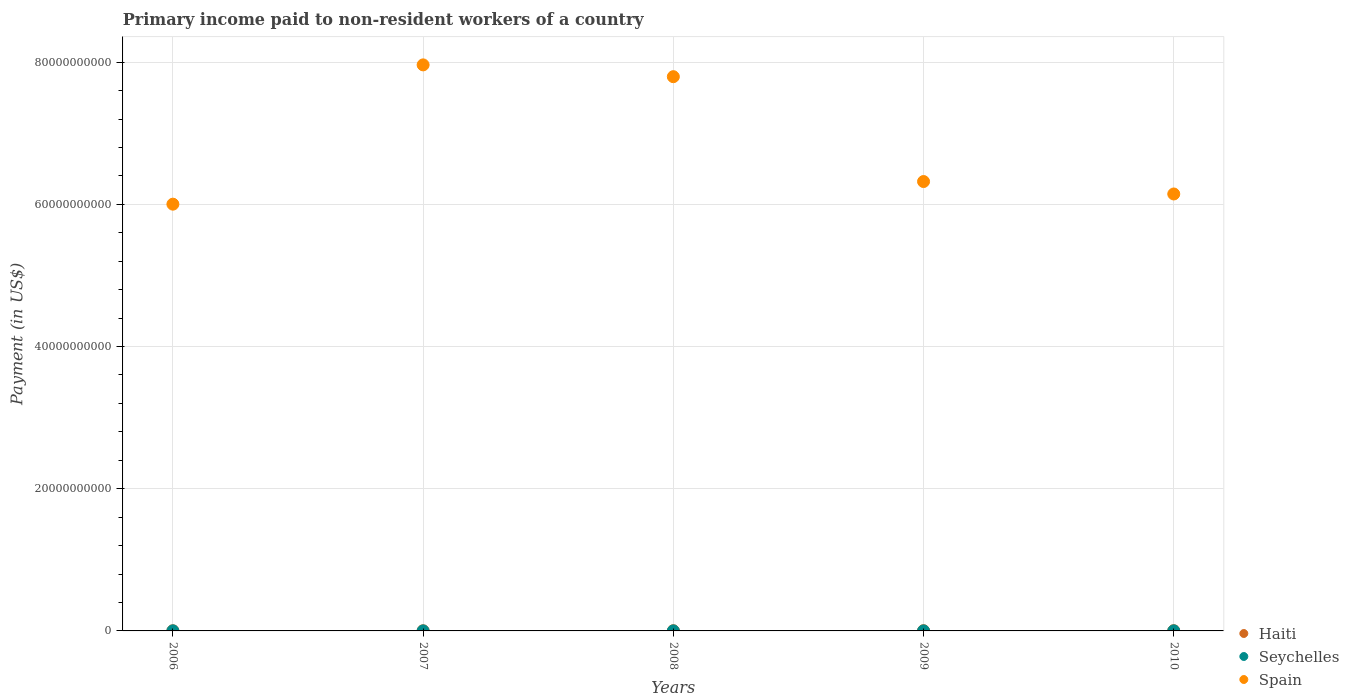Is the number of dotlines equal to the number of legend labels?
Your answer should be compact. Yes. What is the amount paid to workers in Spain in 2010?
Provide a succinct answer. 6.15e+1. Across all years, what is the maximum amount paid to workers in Seychelles?
Your answer should be compact. 1.03e+07. Across all years, what is the minimum amount paid to workers in Seychelles?
Your response must be concise. 3.58e+06. In which year was the amount paid to workers in Seychelles maximum?
Provide a succinct answer. 2006. What is the total amount paid to workers in Seychelles in the graph?
Provide a succinct answer. 3.19e+07. What is the difference between the amount paid to workers in Seychelles in 2006 and that in 2010?
Your answer should be very brief. 6.96e+05. What is the difference between the amount paid to workers in Haiti in 2009 and the amount paid to workers in Seychelles in 2008?
Keep it short and to the point. 2.62e+07. What is the average amount paid to workers in Spain per year?
Offer a terse response. 6.85e+1. In the year 2009, what is the difference between the amount paid to workers in Haiti and amount paid to workers in Spain?
Provide a succinct answer. -6.32e+1. In how many years, is the amount paid to workers in Haiti greater than 60000000000 US$?
Keep it short and to the point. 0. What is the ratio of the amount paid to workers in Seychelles in 2008 to that in 2010?
Make the answer very short. 0.51. Is the amount paid to workers in Haiti in 2007 less than that in 2009?
Keep it short and to the point. Yes. What is the difference between the highest and the second highest amount paid to workers in Spain?
Your response must be concise. 1.66e+09. What is the difference between the highest and the lowest amount paid to workers in Spain?
Provide a short and direct response. 1.96e+1. Is it the case that in every year, the sum of the amount paid to workers in Spain and amount paid to workers in Seychelles  is greater than the amount paid to workers in Haiti?
Your answer should be compact. Yes. Does the amount paid to workers in Seychelles monotonically increase over the years?
Make the answer very short. No. Is the amount paid to workers in Haiti strictly greater than the amount paid to workers in Seychelles over the years?
Make the answer very short. Yes. How many dotlines are there?
Provide a succinct answer. 3. How many years are there in the graph?
Your answer should be compact. 5. What is the difference between two consecutive major ticks on the Y-axis?
Your answer should be very brief. 2.00e+1. Are the values on the major ticks of Y-axis written in scientific E-notation?
Your response must be concise. No. Does the graph contain grids?
Make the answer very short. Yes. Where does the legend appear in the graph?
Your response must be concise. Bottom right. How many legend labels are there?
Ensure brevity in your answer.  3. How are the legend labels stacked?
Keep it short and to the point. Vertical. What is the title of the graph?
Keep it short and to the point. Primary income paid to non-resident workers of a country. What is the label or title of the X-axis?
Your answer should be very brief. Years. What is the label or title of the Y-axis?
Make the answer very short. Payment (in US$). What is the Payment (in US$) in Haiti in 2006?
Offer a very short reply. 2.08e+07. What is the Payment (in US$) in Seychelles in 2006?
Your answer should be compact. 1.03e+07. What is the Payment (in US$) of Spain in 2006?
Your response must be concise. 6.00e+1. What is the Payment (in US$) of Haiti in 2007?
Your answer should be compact. 2.18e+07. What is the Payment (in US$) in Seychelles in 2007?
Your answer should be very brief. 3.58e+06. What is the Payment (in US$) of Spain in 2007?
Give a very brief answer. 7.96e+1. What is the Payment (in US$) of Haiti in 2008?
Ensure brevity in your answer.  2.80e+07. What is the Payment (in US$) in Seychelles in 2008?
Your response must be concise. 4.88e+06. What is the Payment (in US$) of Spain in 2008?
Offer a terse response. 7.80e+1. What is the Payment (in US$) in Haiti in 2009?
Make the answer very short. 3.11e+07. What is the Payment (in US$) in Seychelles in 2009?
Your answer should be compact. 3.65e+06. What is the Payment (in US$) of Spain in 2009?
Provide a short and direct response. 6.32e+1. What is the Payment (in US$) in Haiti in 2010?
Provide a short and direct response. 3.27e+07. What is the Payment (in US$) in Seychelles in 2010?
Your answer should be compact. 9.57e+06. What is the Payment (in US$) of Spain in 2010?
Ensure brevity in your answer.  6.15e+1. Across all years, what is the maximum Payment (in US$) in Haiti?
Give a very brief answer. 3.27e+07. Across all years, what is the maximum Payment (in US$) of Seychelles?
Ensure brevity in your answer.  1.03e+07. Across all years, what is the maximum Payment (in US$) of Spain?
Keep it short and to the point. 7.96e+1. Across all years, what is the minimum Payment (in US$) in Haiti?
Offer a terse response. 2.08e+07. Across all years, what is the minimum Payment (in US$) in Seychelles?
Your answer should be compact. 3.58e+06. Across all years, what is the minimum Payment (in US$) in Spain?
Keep it short and to the point. 6.00e+1. What is the total Payment (in US$) in Haiti in the graph?
Give a very brief answer. 1.34e+08. What is the total Payment (in US$) in Seychelles in the graph?
Your answer should be compact. 3.19e+07. What is the total Payment (in US$) in Spain in the graph?
Offer a very short reply. 3.42e+11. What is the difference between the Payment (in US$) of Haiti in 2006 and that in 2007?
Your answer should be very brief. -9.59e+05. What is the difference between the Payment (in US$) in Seychelles in 2006 and that in 2007?
Keep it short and to the point. 6.69e+06. What is the difference between the Payment (in US$) of Spain in 2006 and that in 2007?
Keep it short and to the point. -1.96e+1. What is the difference between the Payment (in US$) of Haiti in 2006 and that in 2008?
Your response must be concise. -7.19e+06. What is the difference between the Payment (in US$) of Seychelles in 2006 and that in 2008?
Ensure brevity in your answer.  5.39e+06. What is the difference between the Payment (in US$) of Spain in 2006 and that in 2008?
Your answer should be compact. -1.79e+1. What is the difference between the Payment (in US$) of Haiti in 2006 and that in 2009?
Ensure brevity in your answer.  -1.03e+07. What is the difference between the Payment (in US$) of Seychelles in 2006 and that in 2009?
Keep it short and to the point. 6.62e+06. What is the difference between the Payment (in US$) in Spain in 2006 and that in 2009?
Your answer should be compact. -3.18e+09. What is the difference between the Payment (in US$) of Haiti in 2006 and that in 2010?
Provide a succinct answer. -1.19e+07. What is the difference between the Payment (in US$) of Seychelles in 2006 and that in 2010?
Offer a very short reply. 6.96e+05. What is the difference between the Payment (in US$) of Spain in 2006 and that in 2010?
Provide a succinct answer. -1.43e+09. What is the difference between the Payment (in US$) of Haiti in 2007 and that in 2008?
Give a very brief answer. -6.23e+06. What is the difference between the Payment (in US$) in Seychelles in 2007 and that in 2008?
Provide a succinct answer. -1.31e+06. What is the difference between the Payment (in US$) of Spain in 2007 and that in 2008?
Make the answer very short. 1.66e+09. What is the difference between the Payment (in US$) of Haiti in 2007 and that in 2009?
Your response must be concise. -9.33e+06. What is the difference between the Payment (in US$) in Seychelles in 2007 and that in 2009?
Offer a very short reply. -7.35e+04. What is the difference between the Payment (in US$) in Spain in 2007 and that in 2009?
Ensure brevity in your answer.  1.64e+1. What is the difference between the Payment (in US$) in Haiti in 2007 and that in 2010?
Your response must be concise. -1.09e+07. What is the difference between the Payment (in US$) in Seychelles in 2007 and that in 2010?
Offer a terse response. -6.00e+06. What is the difference between the Payment (in US$) in Spain in 2007 and that in 2010?
Your answer should be compact. 1.82e+1. What is the difference between the Payment (in US$) in Haiti in 2008 and that in 2009?
Your answer should be compact. -3.10e+06. What is the difference between the Payment (in US$) in Seychelles in 2008 and that in 2009?
Your answer should be compact. 1.23e+06. What is the difference between the Payment (in US$) of Spain in 2008 and that in 2009?
Keep it short and to the point. 1.47e+1. What is the difference between the Payment (in US$) in Haiti in 2008 and that in 2010?
Offer a very short reply. -4.68e+06. What is the difference between the Payment (in US$) of Seychelles in 2008 and that in 2010?
Your answer should be very brief. -4.69e+06. What is the difference between the Payment (in US$) of Spain in 2008 and that in 2010?
Make the answer very short. 1.65e+1. What is the difference between the Payment (in US$) of Haiti in 2009 and that in 2010?
Your response must be concise. -1.58e+06. What is the difference between the Payment (in US$) of Seychelles in 2009 and that in 2010?
Ensure brevity in your answer.  -5.92e+06. What is the difference between the Payment (in US$) in Spain in 2009 and that in 2010?
Provide a short and direct response. 1.75e+09. What is the difference between the Payment (in US$) in Haiti in 2006 and the Payment (in US$) in Seychelles in 2007?
Your answer should be compact. 1.73e+07. What is the difference between the Payment (in US$) in Haiti in 2006 and the Payment (in US$) in Spain in 2007?
Your answer should be very brief. -7.96e+1. What is the difference between the Payment (in US$) of Seychelles in 2006 and the Payment (in US$) of Spain in 2007?
Keep it short and to the point. -7.96e+1. What is the difference between the Payment (in US$) in Haiti in 2006 and the Payment (in US$) in Seychelles in 2008?
Ensure brevity in your answer.  1.60e+07. What is the difference between the Payment (in US$) of Haiti in 2006 and the Payment (in US$) of Spain in 2008?
Offer a very short reply. -7.79e+1. What is the difference between the Payment (in US$) in Seychelles in 2006 and the Payment (in US$) in Spain in 2008?
Your answer should be compact. -7.79e+1. What is the difference between the Payment (in US$) in Haiti in 2006 and the Payment (in US$) in Seychelles in 2009?
Your answer should be very brief. 1.72e+07. What is the difference between the Payment (in US$) in Haiti in 2006 and the Payment (in US$) in Spain in 2009?
Provide a short and direct response. -6.32e+1. What is the difference between the Payment (in US$) in Seychelles in 2006 and the Payment (in US$) in Spain in 2009?
Provide a short and direct response. -6.32e+1. What is the difference between the Payment (in US$) in Haiti in 2006 and the Payment (in US$) in Seychelles in 2010?
Make the answer very short. 1.13e+07. What is the difference between the Payment (in US$) in Haiti in 2006 and the Payment (in US$) in Spain in 2010?
Keep it short and to the point. -6.14e+1. What is the difference between the Payment (in US$) of Seychelles in 2006 and the Payment (in US$) of Spain in 2010?
Provide a short and direct response. -6.14e+1. What is the difference between the Payment (in US$) in Haiti in 2007 and the Payment (in US$) in Seychelles in 2008?
Keep it short and to the point. 1.69e+07. What is the difference between the Payment (in US$) of Haiti in 2007 and the Payment (in US$) of Spain in 2008?
Give a very brief answer. -7.79e+1. What is the difference between the Payment (in US$) in Seychelles in 2007 and the Payment (in US$) in Spain in 2008?
Your response must be concise. -7.80e+1. What is the difference between the Payment (in US$) in Haiti in 2007 and the Payment (in US$) in Seychelles in 2009?
Offer a terse response. 1.81e+07. What is the difference between the Payment (in US$) in Haiti in 2007 and the Payment (in US$) in Spain in 2009?
Provide a succinct answer. -6.32e+1. What is the difference between the Payment (in US$) of Seychelles in 2007 and the Payment (in US$) of Spain in 2009?
Offer a terse response. -6.32e+1. What is the difference between the Payment (in US$) of Haiti in 2007 and the Payment (in US$) of Seychelles in 2010?
Provide a succinct answer. 1.22e+07. What is the difference between the Payment (in US$) in Haiti in 2007 and the Payment (in US$) in Spain in 2010?
Keep it short and to the point. -6.14e+1. What is the difference between the Payment (in US$) of Seychelles in 2007 and the Payment (in US$) of Spain in 2010?
Your answer should be very brief. -6.15e+1. What is the difference between the Payment (in US$) in Haiti in 2008 and the Payment (in US$) in Seychelles in 2009?
Offer a terse response. 2.44e+07. What is the difference between the Payment (in US$) in Haiti in 2008 and the Payment (in US$) in Spain in 2009?
Provide a succinct answer. -6.32e+1. What is the difference between the Payment (in US$) in Seychelles in 2008 and the Payment (in US$) in Spain in 2009?
Ensure brevity in your answer.  -6.32e+1. What is the difference between the Payment (in US$) in Haiti in 2008 and the Payment (in US$) in Seychelles in 2010?
Give a very brief answer. 1.85e+07. What is the difference between the Payment (in US$) in Haiti in 2008 and the Payment (in US$) in Spain in 2010?
Your response must be concise. -6.14e+1. What is the difference between the Payment (in US$) in Seychelles in 2008 and the Payment (in US$) in Spain in 2010?
Offer a very short reply. -6.15e+1. What is the difference between the Payment (in US$) in Haiti in 2009 and the Payment (in US$) in Seychelles in 2010?
Provide a short and direct response. 2.16e+07. What is the difference between the Payment (in US$) of Haiti in 2009 and the Payment (in US$) of Spain in 2010?
Make the answer very short. -6.14e+1. What is the difference between the Payment (in US$) of Seychelles in 2009 and the Payment (in US$) of Spain in 2010?
Offer a very short reply. -6.15e+1. What is the average Payment (in US$) in Haiti per year?
Your answer should be very brief. 2.69e+07. What is the average Payment (in US$) of Seychelles per year?
Make the answer very short. 6.39e+06. What is the average Payment (in US$) in Spain per year?
Ensure brevity in your answer.  6.85e+1. In the year 2006, what is the difference between the Payment (in US$) of Haiti and Payment (in US$) of Seychelles?
Make the answer very short. 1.06e+07. In the year 2006, what is the difference between the Payment (in US$) in Haiti and Payment (in US$) in Spain?
Ensure brevity in your answer.  -6.00e+1. In the year 2006, what is the difference between the Payment (in US$) of Seychelles and Payment (in US$) of Spain?
Offer a terse response. -6.00e+1. In the year 2007, what is the difference between the Payment (in US$) in Haiti and Payment (in US$) in Seychelles?
Make the answer very short. 1.82e+07. In the year 2007, what is the difference between the Payment (in US$) in Haiti and Payment (in US$) in Spain?
Make the answer very short. -7.96e+1. In the year 2007, what is the difference between the Payment (in US$) in Seychelles and Payment (in US$) in Spain?
Your answer should be very brief. -7.96e+1. In the year 2008, what is the difference between the Payment (in US$) in Haiti and Payment (in US$) in Seychelles?
Keep it short and to the point. 2.31e+07. In the year 2008, what is the difference between the Payment (in US$) of Haiti and Payment (in US$) of Spain?
Your response must be concise. -7.79e+1. In the year 2008, what is the difference between the Payment (in US$) in Seychelles and Payment (in US$) in Spain?
Offer a very short reply. -7.79e+1. In the year 2009, what is the difference between the Payment (in US$) in Haiti and Payment (in US$) in Seychelles?
Your answer should be very brief. 2.75e+07. In the year 2009, what is the difference between the Payment (in US$) of Haiti and Payment (in US$) of Spain?
Offer a very short reply. -6.32e+1. In the year 2009, what is the difference between the Payment (in US$) in Seychelles and Payment (in US$) in Spain?
Keep it short and to the point. -6.32e+1. In the year 2010, what is the difference between the Payment (in US$) in Haiti and Payment (in US$) in Seychelles?
Make the answer very short. 2.31e+07. In the year 2010, what is the difference between the Payment (in US$) of Haiti and Payment (in US$) of Spain?
Keep it short and to the point. -6.14e+1. In the year 2010, what is the difference between the Payment (in US$) in Seychelles and Payment (in US$) in Spain?
Keep it short and to the point. -6.14e+1. What is the ratio of the Payment (in US$) in Haiti in 2006 to that in 2007?
Your answer should be very brief. 0.96. What is the ratio of the Payment (in US$) of Seychelles in 2006 to that in 2007?
Your answer should be compact. 2.87. What is the ratio of the Payment (in US$) of Spain in 2006 to that in 2007?
Offer a terse response. 0.75. What is the ratio of the Payment (in US$) in Haiti in 2006 to that in 2008?
Keep it short and to the point. 0.74. What is the ratio of the Payment (in US$) in Seychelles in 2006 to that in 2008?
Provide a succinct answer. 2.1. What is the ratio of the Payment (in US$) in Spain in 2006 to that in 2008?
Make the answer very short. 0.77. What is the ratio of the Payment (in US$) of Haiti in 2006 to that in 2009?
Offer a very short reply. 0.67. What is the ratio of the Payment (in US$) of Seychelles in 2006 to that in 2009?
Provide a short and direct response. 2.81. What is the ratio of the Payment (in US$) of Spain in 2006 to that in 2009?
Make the answer very short. 0.95. What is the ratio of the Payment (in US$) of Haiti in 2006 to that in 2010?
Offer a very short reply. 0.64. What is the ratio of the Payment (in US$) of Seychelles in 2006 to that in 2010?
Your answer should be very brief. 1.07. What is the ratio of the Payment (in US$) of Spain in 2006 to that in 2010?
Make the answer very short. 0.98. What is the ratio of the Payment (in US$) in Haiti in 2007 to that in 2008?
Offer a terse response. 0.78. What is the ratio of the Payment (in US$) of Seychelles in 2007 to that in 2008?
Ensure brevity in your answer.  0.73. What is the ratio of the Payment (in US$) of Spain in 2007 to that in 2008?
Provide a succinct answer. 1.02. What is the ratio of the Payment (in US$) in Haiti in 2007 to that in 2009?
Your answer should be compact. 0.7. What is the ratio of the Payment (in US$) of Seychelles in 2007 to that in 2009?
Your answer should be very brief. 0.98. What is the ratio of the Payment (in US$) in Spain in 2007 to that in 2009?
Offer a very short reply. 1.26. What is the ratio of the Payment (in US$) in Haiti in 2007 to that in 2010?
Provide a short and direct response. 0.67. What is the ratio of the Payment (in US$) of Seychelles in 2007 to that in 2010?
Offer a terse response. 0.37. What is the ratio of the Payment (in US$) of Spain in 2007 to that in 2010?
Keep it short and to the point. 1.3. What is the ratio of the Payment (in US$) in Haiti in 2008 to that in 2009?
Make the answer very short. 0.9. What is the ratio of the Payment (in US$) of Seychelles in 2008 to that in 2009?
Your answer should be compact. 1.34. What is the ratio of the Payment (in US$) in Spain in 2008 to that in 2009?
Make the answer very short. 1.23. What is the ratio of the Payment (in US$) in Haiti in 2008 to that in 2010?
Provide a short and direct response. 0.86. What is the ratio of the Payment (in US$) of Seychelles in 2008 to that in 2010?
Provide a succinct answer. 0.51. What is the ratio of the Payment (in US$) in Spain in 2008 to that in 2010?
Make the answer very short. 1.27. What is the ratio of the Payment (in US$) in Haiti in 2009 to that in 2010?
Your answer should be compact. 0.95. What is the ratio of the Payment (in US$) of Seychelles in 2009 to that in 2010?
Offer a very short reply. 0.38. What is the ratio of the Payment (in US$) in Spain in 2009 to that in 2010?
Make the answer very short. 1.03. What is the difference between the highest and the second highest Payment (in US$) in Haiti?
Your answer should be very brief. 1.58e+06. What is the difference between the highest and the second highest Payment (in US$) in Seychelles?
Your answer should be compact. 6.96e+05. What is the difference between the highest and the second highest Payment (in US$) in Spain?
Your answer should be compact. 1.66e+09. What is the difference between the highest and the lowest Payment (in US$) in Haiti?
Offer a very short reply. 1.19e+07. What is the difference between the highest and the lowest Payment (in US$) of Seychelles?
Your answer should be very brief. 6.69e+06. What is the difference between the highest and the lowest Payment (in US$) in Spain?
Provide a short and direct response. 1.96e+1. 